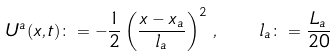Convert formula to latex. <formula><loc_0><loc_0><loc_500><loc_500>U ^ { a } ( x , t ) \colon = - \frac { 1 } { 2 } \left ( \frac { x - x _ { a } } { l _ { a } } \right ) ^ { 2 } \, , \quad l _ { a } \colon = \frac { L _ { a } } { 2 0 }</formula> 